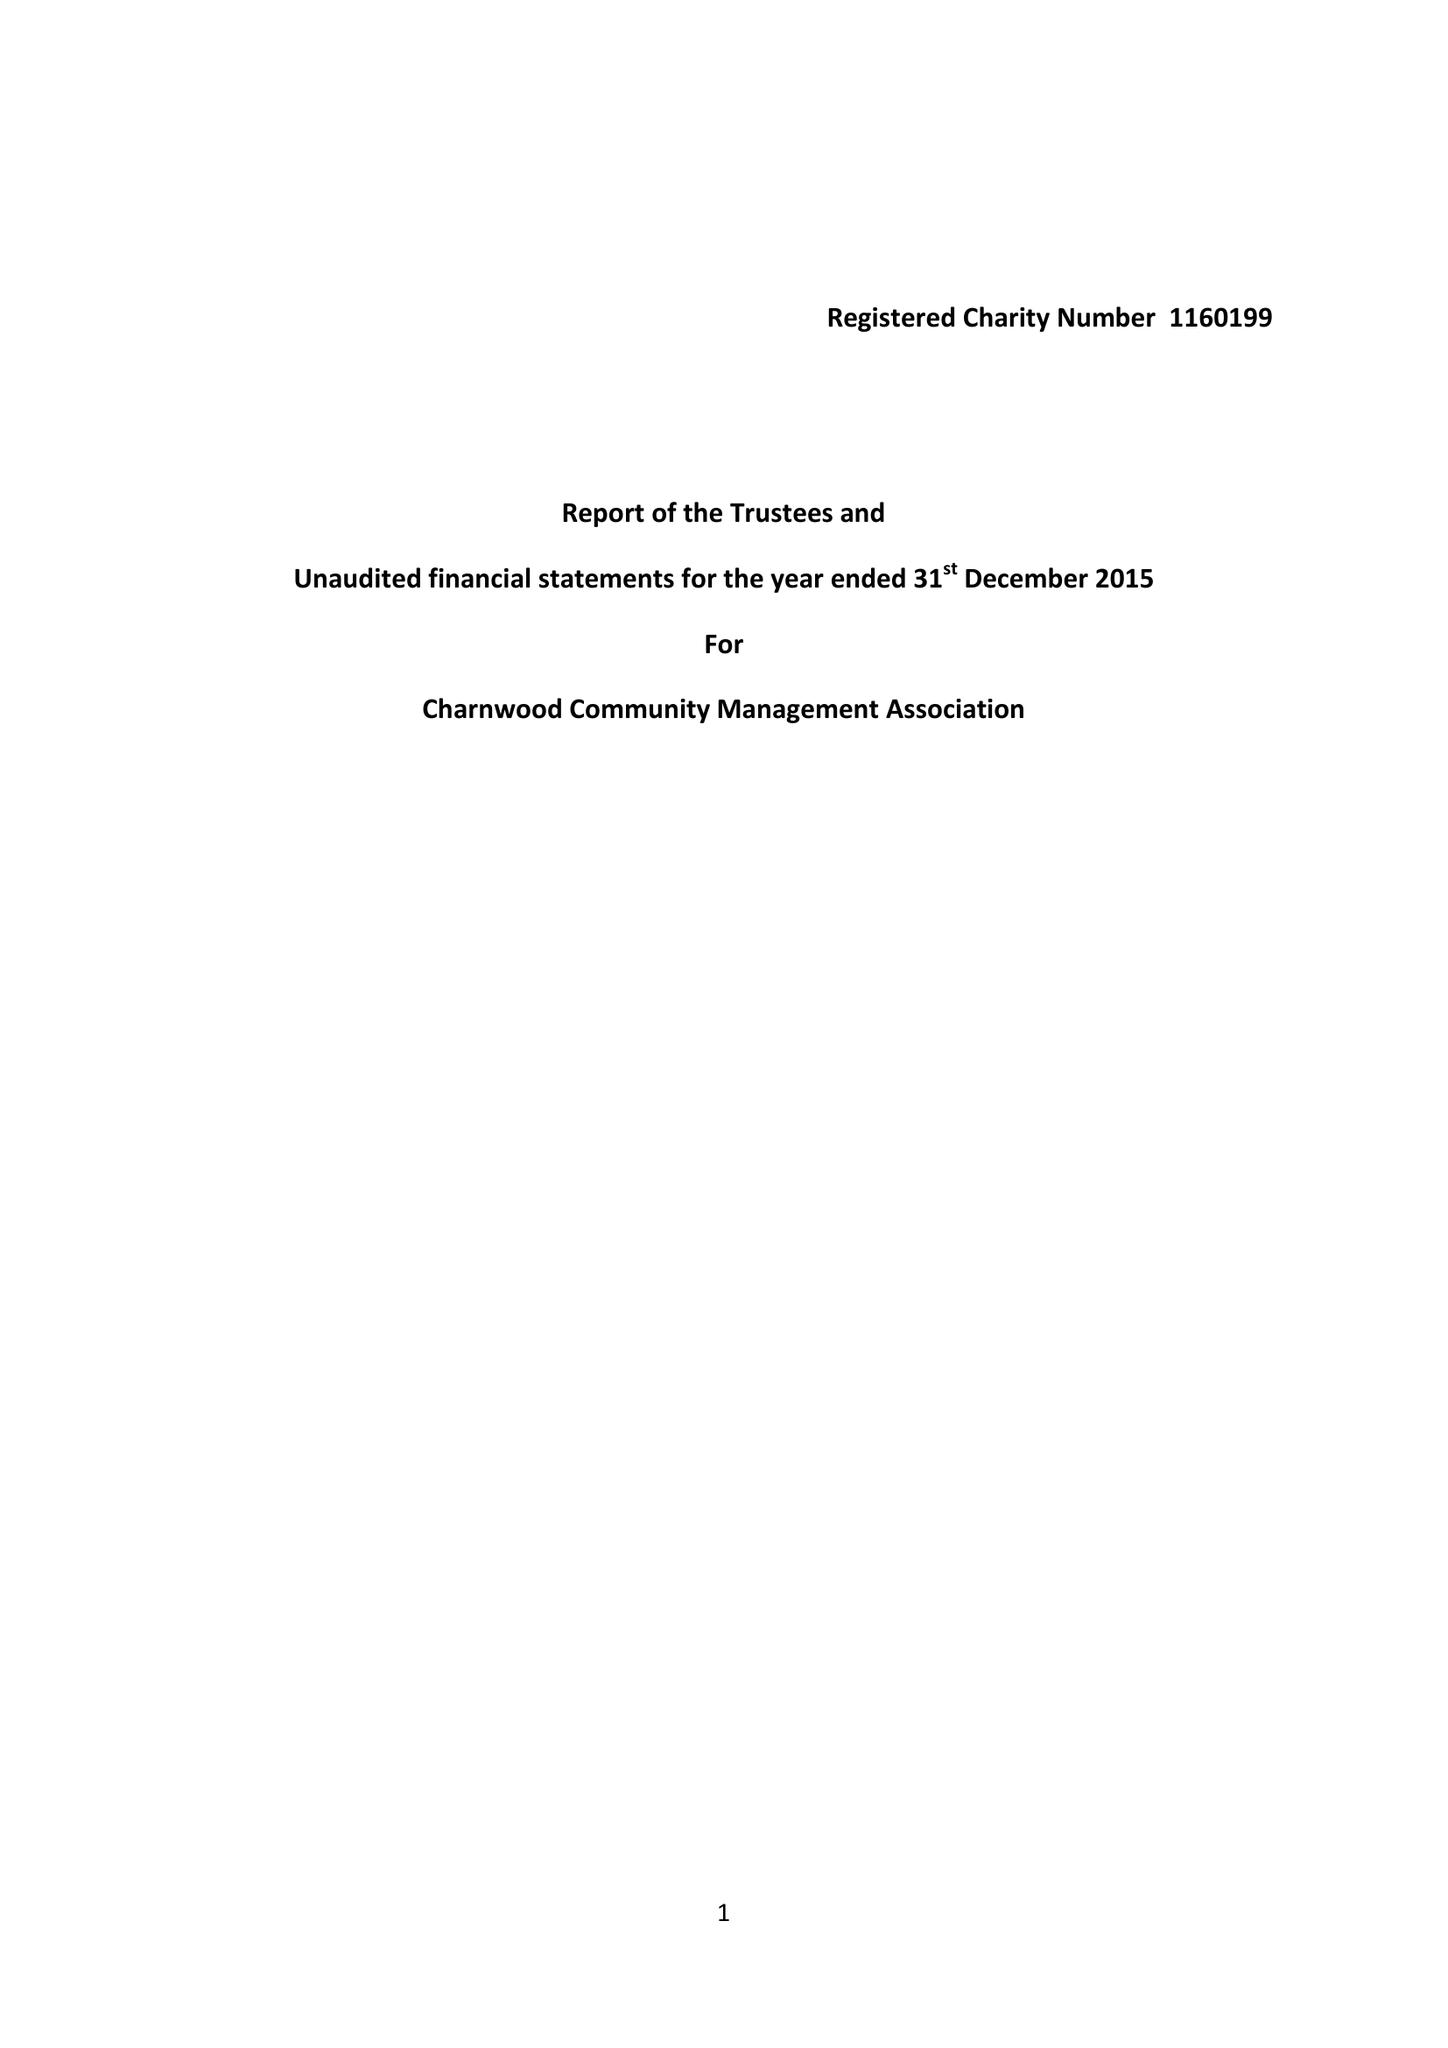What is the value for the charity_number?
Answer the question using a single word or phrase. 1160199 